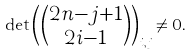<formula> <loc_0><loc_0><loc_500><loc_500>\det \begin{pmatrix} \binom { 2 n - j + 1 } { 2 i - 1 } \end{pmatrix} _ { i , j } \neq 0 .</formula> 